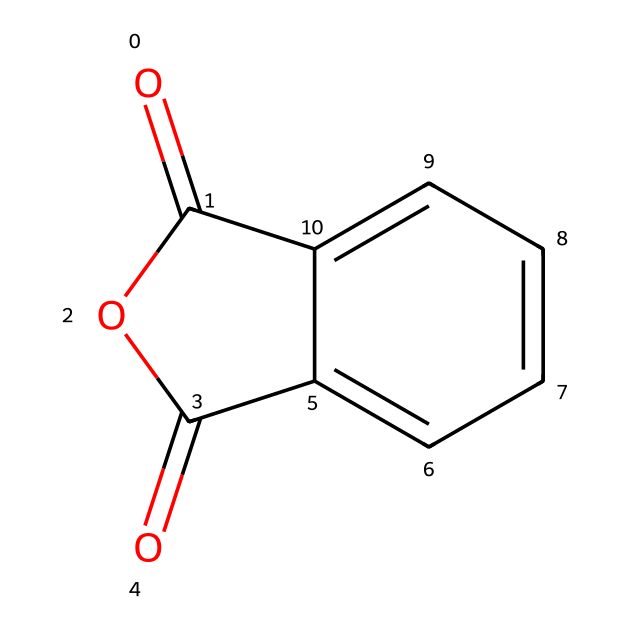What is the name of this chemical? The chemical structure corresponds to phthalic anhydride, which is well-known for its use in various applications including adhesives. The visual representation, including the carbonyl and cyclic structure, gives clues about its identity.
Answer: phthalic anhydride How many carbon atoms are in this structure? By examining the SMILES representation, there are six carbon atoms in the aromatic ring and two more in the anhydride group, totaling eight carbon atoms. This can be confirmed by counting each 'C' in the representation.
Answer: eight What functional group characterizes this chemical? The structural formula shows a cyclic anhydride functional group with carbonyl (C=O) groups. The presence of these carbonyls adjacent to an ether-like oxygen indicates that it is an anhydride.
Answer: anhydride What is the total number of oxygen atoms present? From the SMILES, there are two carbonyl oxygen atoms and one ether-like oxygen atom, resulting in a total of three oxygen atoms in the structure. This is counted directly from the visual representation and the provided SMILES.
Answer: three Is this chemical soluble in water? **No**, phthalic anhydride is generally considered to be insoluble in water due to its hydrophobic aromatic structure which limits its interactions with polar water molecules. Instead, it is soluble in organic solvents.
Answer: no What type of reaction can phthalic anhydride undergo? Phthalic anhydride can undergo hydrolysis, creating phthalic acid upon reaction with water. This can be inferred from its structure, as the anhydride group is reactive towards nucleophiles, particularly water.
Answer: hydrolysis What is one common application of phthalic anhydride? Phthalic anhydride is commonly used in the production of adhesives, plasticizers, and resins. Its chemical structure and properties make it effective for these industrial applications.
Answer: adhesives 